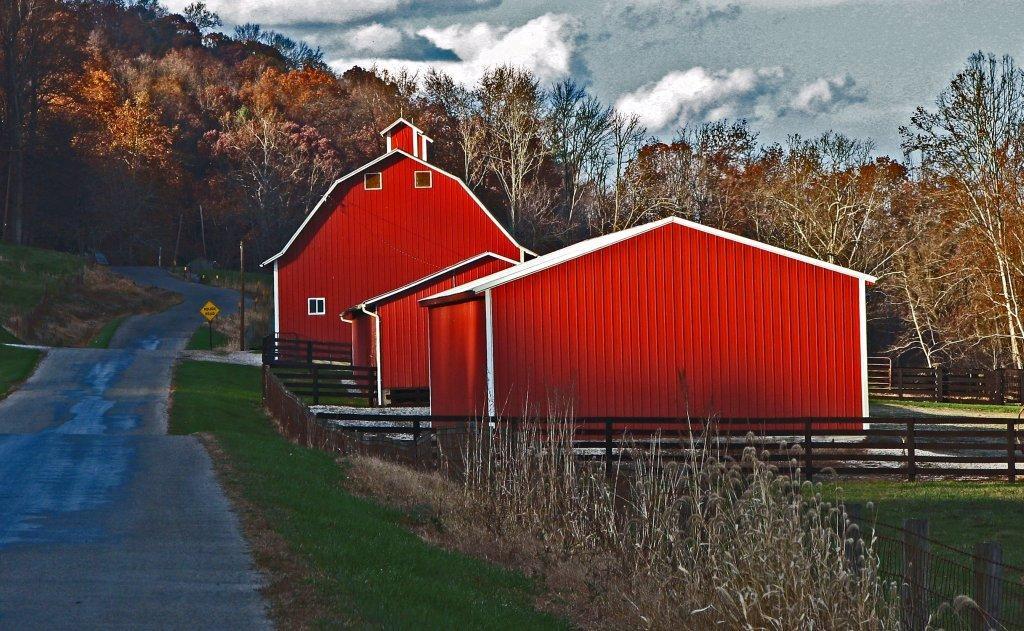Could you give a brief overview of what you see in this image? The picture is taken outside the city, on the road. In the foreground of the picture there are plants, grass, fencing, fields and road. In the center of the picture there are houses, fencing, sign boards, poles, grass. In the background there are trees. Sky is bit cloudy and it is sunny. 